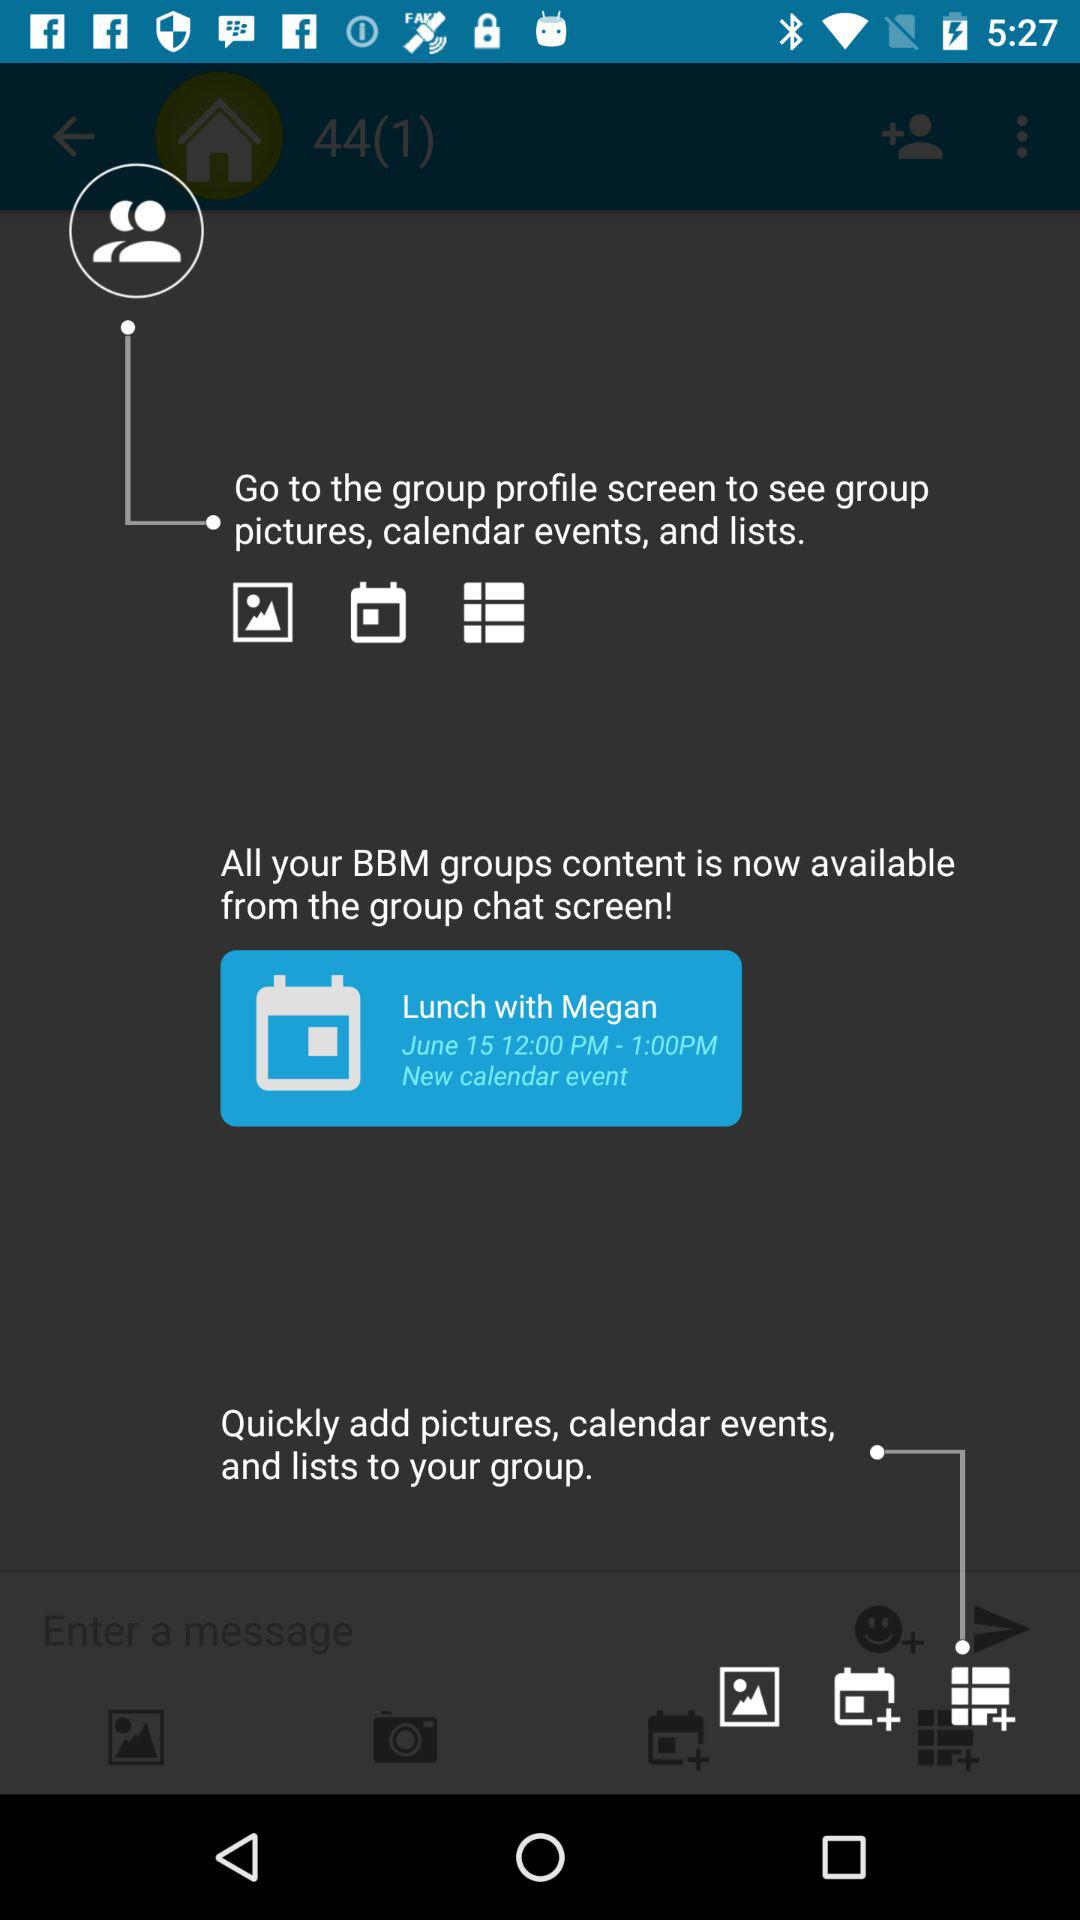What is the date of the event? The date of the event is June 15. 